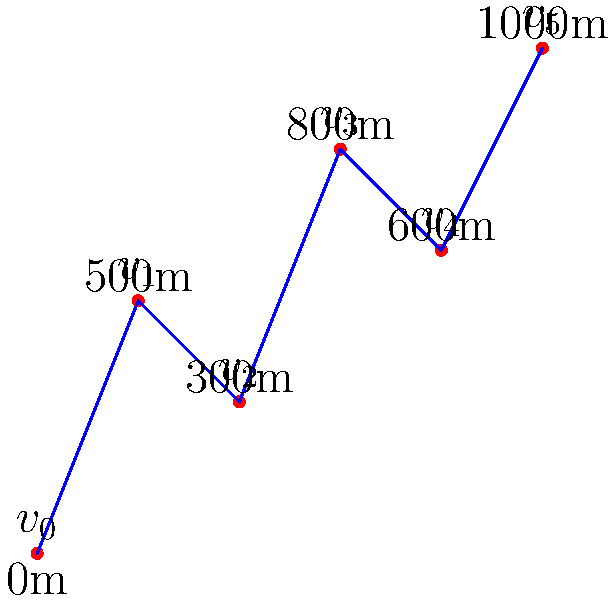A mountain stage in a cycling race is represented by the graph above, where each vertex represents a checkpoint and the edges represent the paths between them. The elevation of each checkpoint is given. Using graph theory, determine the total elevation gain for the most efficient climbing strategy from $v_0$ to $v_5$. To find the most efficient climbing strategy and calculate the total elevation gain, we'll follow these steps:

1. Identify the elevations for each vertex:
   $v_0$: 0m
   $v_1$: 500m
   $v_2$: 300m
   $v_3$: 800m
   $v_4$: 600m
   $v_5$: 1000m

2. Calculate the elevation changes between consecutive vertices:
   $v_0$ to $v_1$: 500m gain
   $v_1$ to $v_2$: 200m loss
   $v_2$ to $v_3$: 500m gain
   $v_3$ to $v_4$: 200m loss
   $v_4$ to $v_5$: 400m gain

3. The most efficient climbing strategy is to only count positive elevation changes, as descents don't contribute to the total elevation gain.

4. Sum up the positive elevation changes:
   500m + 500m + 400m = 1400m

Therefore, the total elevation gain for the most efficient climbing strategy from $v_0$ to $v_5$ is 1400 meters.
Answer: 1400 meters 